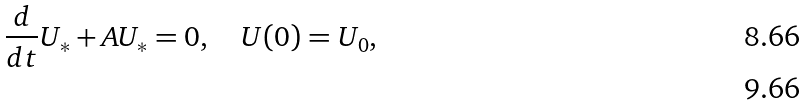Convert formula to latex. <formula><loc_0><loc_0><loc_500><loc_500>\frac { d } { d t } U _ { * } + A U _ { * } = 0 , \quad U ( 0 ) = U _ { 0 } , \\</formula> 